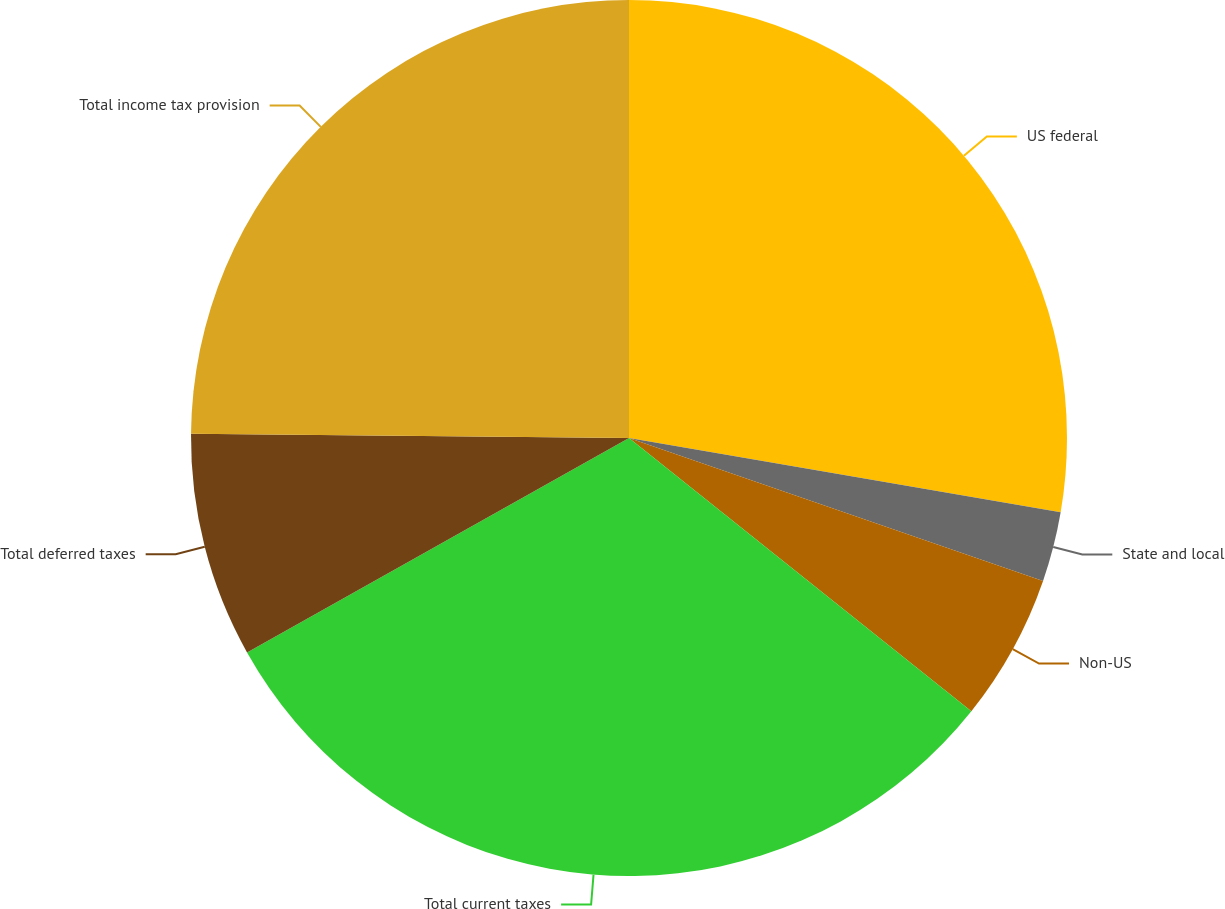<chart> <loc_0><loc_0><loc_500><loc_500><pie_chart><fcel>US federal<fcel>State and local<fcel>Non-US<fcel>Total current taxes<fcel>Total deferred taxes<fcel>Total income tax provision<nl><fcel>27.71%<fcel>2.58%<fcel>5.43%<fcel>31.14%<fcel>8.29%<fcel>24.85%<nl></chart> 